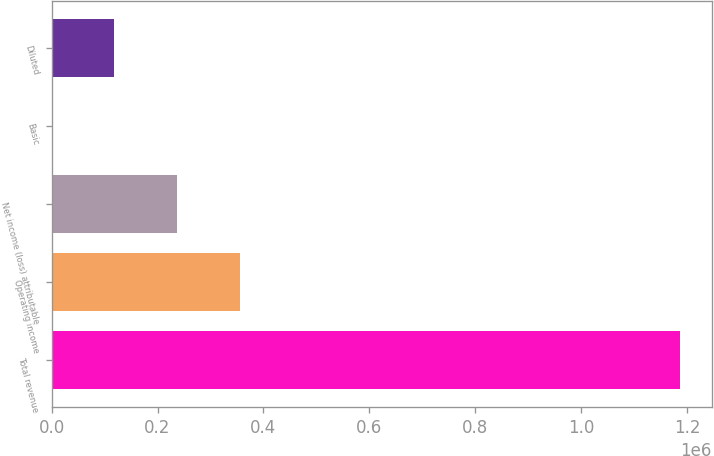Convert chart to OTSL. <chart><loc_0><loc_0><loc_500><loc_500><bar_chart><fcel>Total revenue<fcel>Operating income<fcel>Net income (loss) attributable<fcel>Basic<fcel>Diluted<nl><fcel>1.18684e+06<fcel>356051<fcel>237368<fcel>0.64<fcel>118684<nl></chart> 